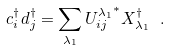Convert formula to latex. <formula><loc_0><loc_0><loc_500><loc_500>c ^ { \dagger } _ { i } d ^ { \dagger } _ { j } = \sum _ { \lambda _ { 1 } } { U ^ { \lambda _ { 1 } } _ { i j } } ^ { * } X ^ { \dagger } _ { \lambda _ { 1 } } \ .</formula> 